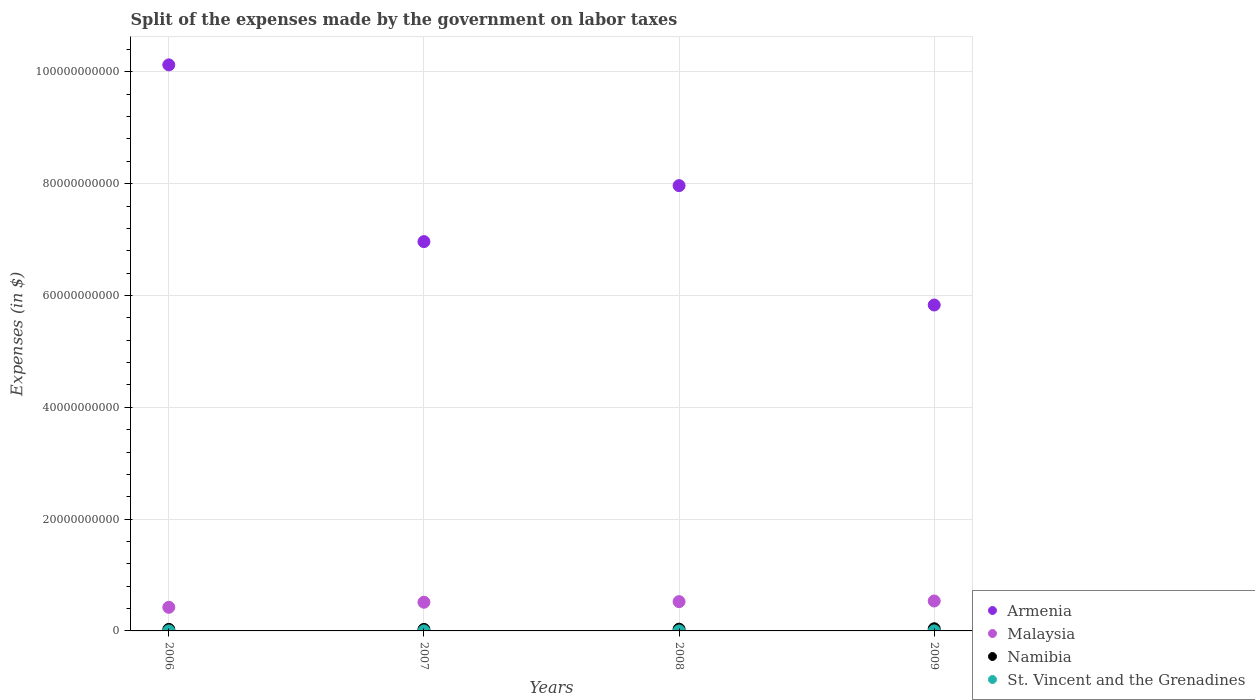What is the expenses made by the government on labor taxes in Malaysia in 2007?
Make the answer very short. 5.13e+09. Across all years, what is the maximum expenses made by the government on labor taxes in Malaysia?
Offer a terse response. 5.35e+09. Across all years, what is the minimum expenses made by the government on labor taxes in St. Vincent and the Grenadines?
Provide a short and direct response. 2.20e+06. In which year was the expenses made by the government on labor taxes in Armenia minimum?
Provide a short and direct response. 2009. What is the total expenses made by the government on labor taxes in St. Vincent and the Grenadines in the graph?
Your answer should be compact. 1.01e+07. What is the difference between the expenses made by the government on labor taxes in Armenia in 2008 and that in 2009?
Give a very brief answer. 2.14e+1. What is the difference between the expenses made by the government on labor taxes in Malaysia in 2006 and the expenses made by the government on labor taxes in Namibia in 2009?
Your answer should be very brief. 3.84e+09. What is the average expenses made by the government on labor taxes in Armenia per year?
Your response must be concise. 7.72e+1. In the year 2009, what is the difference between the expenses made by the government on labor taxes in Armenia and expenses made by the government on labor taxes in St. Vincent and the Grenadines?
Make the answer very short. 5.83e+1. What is the ratio of the expenses made by the government on labor taxes in St. Vincent and the Grenadines in 2007 to that in 2008?
Your response must be concise. 1.18. Is the expenses made by the government on labor taxes in Malaysia in 2006 less than that in 2007?
Make the answer very short. Yes. Is the difference between the expenses made by the government on labor taxes in Armenia in 2006 and 2007 greater than the difference between the expenses made by the government on labor taxes in St. Vincent and the Grenadines in 2006 and 2007?
Provide a succinct answer. Yes. What is the difference between the highest and the second highest expenses made by the government on labor taxes in Malaysia?
Provide a short and direct response. 1.15e+08. What is the difference between the highest and the lowest expenses made by the government on labor taxes in Malaysia?
Provide a succinct answer. 1.13e+09. In how many years, is the expenses made by the government on labor taxes in Malaysia greater than the average expenses made by the government on labor taxes in Malaysia taken over all years?
Make the answer very short. 3. Is it the case that in every year, the sum of the expenses made by the government on labor taxes in Malaysia and expenses made by the government on labor taxes in Armenia  is greater than the sum of expenses made by the government on labor taxes in Namibia and expenses made by the government on labor taxes in St. Vincent and the Grenadines?
Ensure brevity in your answer.  Yes. How many years are there in the graph?
Offer a very short reply. 4. What is the difference between two consecutive major ticks on the Y-axis?
Ensure brevity in your answer.  2.00e+1. Does the graph contain grids?
Your response must be concise. Yes. Where does the legend appear in the graph?
Provide a succinct answer. Bottom right. How many legend labels are there?
Keep it short and to the point. 4. What is the title of the graph?
Your answer should be compact. Split of the expenses made by the government on labor taxes. Does "High income" appear as one of the legend labels in the graph?
Your answer should be very brief. No. What is the label or title of the Y-axis?
Make the answer very short. Expenses (in $). What is the Expenses (in $) in Armenia in 2006?
Offer a very short reply. 1.01e+11. What is the Expenses (in $) in Malaysia in 2006?
Your answer should be compact. 4.23e+09. What is the Expenses (in $) in Namibia in 2006?
Make the answer very short. 2.73e+08. What is the Expenses (in $) of St. Vincent and the Grenadines in 2006?
Make the answer very short. 2.60e+06. What is the Expenses (in $) in Armenia in 2007?
Offer a very short reply. 6.96e+1. What is the Expenses (in $) in Malaysia in 2007?
Your answer should be compact. 5.13e+09. What is the Expenses (in $) in Namibia in 2007?
Provide a succinct answer. 2.68e+08. What is the Expenses (in $) of St. Vincent and the Grenadines in 2007?
Provide a short and direct response. 2.60e+06. What is the Expenses (in $) of Armenia in 2008?
Provide a succinct answer. 7.97e+1. What is the Expenses (in $) in Malaysia in 2008?
Provide a succinct answer. 5.24e+09. What is the Expenses (in $) in Namibia in 2008?
Offer a very short reply. 3.13e+08. What is the Expenses (in $) in St. Vincent and the Grenadines in 2008?
Offer a terse response. 2.20e+06. What is the Expenses (in $) of Armenia in 2009?
Provide a succinct answer. 5.83e+1. What is the Expenses (in $) in Malaysia in 2009?
Ensure brevity in your answer.  5.35e+09. What is the Expenses (in $) in Namibia in 2009?
Give a very brief answer. 3.89e+08. What is the Expenses (in $) of St. Vincent and the Grenadines in 2009?
Your answer should be very brief. 2.70e+06. Across all years, what is the maximum Expenses (in $) in Armenia?
Provide a short and direct response. 1.01e+11. Across all years, what is the maximum Expenses (in $) of Malaysia?
Provide a succinct answer. 5.35e+09. Across all years, what is the maximum Expenses (in $) of Namibia?
Keep it short and to the point. 3.89e+08. Across all years, what is the maximum Expenses (in $) in St. Vincent and the Grenadines?
Make the answer very short. 2.70e+06. Across all years, what is the minimum Expenses (in $) in Armenia?
Your response must be concise. 5.83e+1. Across all years, what is the minimum Expenses (in $) of Malaysia?
Keep it short and to the point. 4.23e+09. Across all years, what is the minimum Expenses (in $) of Namibia?
Give a very brief answer. 2.68e+08. Across all years, what is the minimum Expenses (in $) in St. Vincent and the Grenadines?
Provide a short and direct response. 2.20e+06. What is the total Expenses (in $) of Armenia in the graph?
Your answer should be compact. 3.09e+11. What is the total Expenses (in $) of Malaysia in the graph?
Your answer should be compact. 2.00e+1. What is the total Expenses (in $) in Namibia in the graph?
Ensure brevity in your answer.  1.24e+09. What is the total Expenses (in $) of St. Vincent and the Grenadines in the graph?
Make the answer very short. 1.01e+07. What is the difference between the Expenses (in $) of Armenia in 2006 and that in 2007?
Give a very brief answer. 3.16e+1. What is the difference between the Expenses (in $) in Malaysia in 2006 and that in 2007?
Your answer should be compact. -9.08e+08. What is the difference between the Expenses (in $) in Namibia in 2006 and that in 2007?
Provide a succinct answer. 4.53e+06. What is the difference between the Expenses (in $) in St. Vincent and the Grenadines in 2006 and that in 2007?
Ensure brevity in your answer.  0. What is the difference between the Expenses (in $) in Armenia in 2006 and that in 2008?
Make the answer very short. 2.16e+1. What is the difference between the Expenses (in $) in Malaysia in 2006 and that in 2008?
Offer a terse response. -1.01e+09. What is the difference between the Expenses (in $) in Namibia in 2006 and that in 2008?
Offer a very short reply. -4.08e+07. What is the difference between the Expenses (in $) of St. Vincent and the Grenadines in 2006 and that in 2008?
Offer a very short reply. 4.00e+05. What is the difference between the Expenses (in $) in Armenia in 2006 and that in 2009?
Your response must be concise. 4.30e+1. What is the difference between the Expenses (in $) in Malaysia in 2006 and that in 2009?
Offer a terse response. -1.13e+09. What is the difference between the Expenses (in $) of Namibia in 2006 and that in 2009?
Your response must be concise. -1.16e+08. What is the difference between the Expenses (in $) in Armenia in 2007 and that in 2008?
Give a very brief answer. -1.00e+1. What is the difference between the Expenses (in $) of Malaysia in 2007 and that in 2008?
Make the answer very short. -1.06e+08. What is the difference between the Expenses (in $) of Namibia in 2007 and that in 2008?
Provide a short and direct response. -4.53e+07. What is the difference between the Expenses (in $) in St. Vincent and the Grenadines in 2007 and that in 2008?
Your answer should be compact. 4.00e+05. What is the difference between the Expenses (in $) of Armenia in 2007 and that in 2009?
Offer a very short reply. 1.13e+1. What is the difference between the Expenses (in $) of Malaysia in 2007 and that in 2009?
Provide a short and direct response. -2.21e+08. What is the difference between the Expenses (in $) of Namibia in 2007 and that in 2009?
Make the answer very short. -1.21e+08. What is the difference between the Expenses (in $) in Armenia in 2008 and that in 2009?
Give a very brief answer. 2.14e+1. What is the difference between the Expenses (in $) in Malaysia in 2008 and that in 2009?
Offer a terse response. -1.15e+08. What is the difference between the Expenses (in $) in Namibia in 2008 and that in 2009?
Provide a succinct answer. -7.52e+07. What is the difference between the Expenses (in $) in St. Vincent and the Grenadines in 2008 and that in 2009?
Offer a terse response. -5.00e+05. What is the difference between the Expenses (in $) of Armenia in 2006 and the Expenses (in $) of Malaysia in 2007?
Provide a succinct answer. 9.61e+1. What is the difference between the Expenses (in $) of Armenia in 2006 and the Expenses (in $) of Namibia in 2007?
Make the answer very short. 1.01e+11. What is the difference between the Expenses (in $) in Armenia in 2006 and the Expenses (in $) in St. Vincent and the Grenadines in 2007?
Make the answer very short. 1.01e+11. What is the difference between the Expenses (in $) in Malaysia in 2006 and the Expenses (in $) in Namibia in 2007?
Your answer should be very brief. 3.96e+09. What is the difference between the Expenses (in $) of Malaysia in 2006 and the Expenses (in $) of St. Vincent and the Grenadines in 2007?
Provide a succinct answer. 4.22e+09. What is the difference between the Expenses (in $) in Namibia in 2006 and the Expenses (in $) in St. Vincent and the Grenadines in 2007?
Your response must be concise. 2.70e+08. What is the difference between the Expenses (in $) of Armenia in 2006 and the Expenses (in $) of Malaysia in 2008?
Provide a short and direct response. 9.60e+1. What is the difference between the Expenses (in $) of Armenia in 2006 and the Expenses (in $) of Namibia in 2008?
Give a very brief answer. 1.01e+11. What is the difference between the Expenses (in $) in Armenia in 2006 and the Expenses (in $) in St. Vincent and the Grenadines in 2008?
Your answer should be compact. 1.01e+11. What is the difference between the Expenses (in $) of Malaysia in 2006 and the Expenses (in $) of Namibia in 2008?
Offer a terse response. 3.91e+09. What is the difference between the Expenses (in $) in Malaysia in 2006 and the Expenses (in $) in St. Vincent and the Grenadines in 2008?
Offer a very short reply. 4.22e+09. What is the difference between the Expenses (in $) of Namibia in 2006 and the Expenses (in $) of St. Vincent and the Grenadines in 2008?
Provide a succinct answer. 2.70e+08. What is the difference between the Expenses (in $) of Armenia in 2006 and the Expenses (in $) of Malaysia in 2009?
Your answer should be very brief. 9.59e+1. What is the difference between the Expenses (in $) of Armenia in 2006 and the Expenses (in $) of Namibia in 2009?
Offer a terse response. 1.01e+11. What is the difference between the Expenses (in $) of Armenia in 2006 and the Expenses (in $) of St. Vincent and the Grenadines in 2009?
Keep it short and to the point. 1.01e+11. What is the difference between the Expenses (in $) of Malaysia in 2006 and the Expenses (in $) of Namibia in 2009?
Ensure brevity in your answer.  3.84e+09. What is the difference between the Expenses (in $) of Malaysia in 2006 and the Expenses (in $) of St. Vincent and the Grenadines in 2009?
Make the answer very short. 4.22e+09. What is the difference between the Expenses (in $) of Namibia in 2006 and the Expenses (in $) of St. Vincent and the Grenadines in 2009?
Offer a terse response. 2.70e+08. What is the difference between the Expenses (in $) of Armenia in 2007 and the Expenses (in $) of Malaysia in 2008?
Offer a very short reply. 6.44e+1. What is the difference between the Expenses (in $) of Armenia in 2007 and the Expenses (in $) of Namibia in 2008?
Give a very brief answer. 6.93e+1. What is the difference between the Expenses (in $) of Armenia in 2007 and the Expenses (in $) of St. Vincent and the Grenadines in 2008?
Provide a succinct answer. 6.96e+1. What is the difference between the Expenses (in $) of Malaysia in 2007 and the Expenses (in $) of Namibia in 2008?
Make the answer very short. 4.82e+09. What is the difference between the Expenses (in $) of Malaysia in 2007 and the Expenses (in $) of St. Vincent and the Grenadines in 2008?
Provide a succinct answer. 5.13e+09. What is the difference between the Expenses (in $) of Namibia in 2007 and the Expenses (in $) of St. Vincent and the Grenadines in 2008?
Your answer should be compact. 2.66e+08. What is the difference between the Expenses (in $) in Armenia in 2007 and the Expenses (in $) in Malaysia in 2009?
Offer a very short reply. 6.43e+1. What is the difference between the Expenses (in $) in Armenia in 2007 and the Expenses (in $) in Namibia in 2009?
Offer a terse response. 6.93e+1. What is the difference between the Expenses (in $) of Armenia in 2007 and the Expenses (in $) of St. Vincent and the Grenadines in 2009?
Your answer should be very brief. 6.96e+1. What is the difference between the Expenses (in $) of Malaysia in 2007 and the Expenses (in $) of Namibia in 2009?
Offer a very short reply. 4.74e+09. What is the difference between the Expenses (in $) of Malaysia in 2007 and the Expenses (in $) of St. Vincent and the Grenadines in 2009?
Your answer should be compact. 5.13e+09. What is the difference between the Expenses (in $) in Namibia in 2007 and the Expenses (in $) in St. Vincent and the Grenadines in 2009?
Offer a very short reply. 2.65e+08. What is the difference between the Expenses (in $) of Armenia in 2008 and the Expenses (in $) of Malaysia in 2009?
Offer a very short reply. 7.43e+1. What is the difference between the Expenses (in $) of Armenia in 2008 and the Expenses (in $) of Namibia in 2009?
Your response must be concise. 7.93e+1. What is the difference between the Expenses (in $) in Armenia in 2008 and the Expenses (in $) in St. Vincent and the Grenadines in 2009?
Ensure brevity in your answer.  7.96e+1. What is the difference between the Expenses (in $) of Malaysia in 2008 and the Expenses (in $) of Namibia in 2009?
Keep it short and to the point. 4.85e+09. What is the difference between the Expenses (in $) of Malaysia in 2008 and the Expenses (in $) of St. Vincent and the Grenadines in 2009?
Offer a very short reply. 5.24e+09. What is the difference between the Expenses (in $) of Namibia in 2008 and the Expenses (in $) of St. Vincent and the Grenadines in 2009?
Provide a succinct answer. 3.11e+08. What is the average Expenses (in $) of Armenia per year?
Your response must be concise. 7.72e+1. What is the average Expenses (in $) of Malaysia per year?
Provide a succinct answer. 4.99e+09. What is the average Expenses (in $) in Namibia per year?
Ensure brevity in your answer.  3.11e+08. What is the average Expenses (in $) in St. Vincent and the Grenadines per year?
Your answer should be compact. 2.52e+06. In the year 2006, what is the difference between the Expenses (in $) of Armenia and Expenses (in $) of Malaysia?
Make the answer very short. 9.70e+1. In the year 2006, what is the difference between the Expenses (in $) in Armenia and Expenses (in $) in Namibia?
Give a very brief answer. 1.01e+11. In the year 2006, what is the difference between the Expenses (in $) in Armenia and Expenses (in $) in St. Vincent and the Grenadines?
Provide a succinct answer. 1.01e+11. In the year 2006, what is the difference between the Expenses (in $) of Malaysia and Expenses (in $) of Namibia?
Offer a very short reply. 3.95e+09. In the year 2006, what is the difference between the Expenses (in $) in Malaysia and Expenses (in $) in St. Vincent and the Grenadines?
Your answer should be compact. 4.22e+09. In the year 2006, what is the difference between the Expenses (in $) of Namibia and Expenses (in $) of St. Vincent and the Grenadines?
Keep it short and to the point. 2.70e+08. In the year 2007, what is the difference between the Expenses (in $) in Armenia and Expenses (in $) in Malaysia?
Keep it short and to the point. 6.45e+1. In the year 2007, what is the difference between the Expenses (in $) in Armenia and Expenses (in $) in Namibia?
Make the answer very short. 6.94e+1. In the year 2007, what is the difference between the Expenses (in $) of Armenia and Expenses (in $) of St. Vincent and the Grenadines?
Offer a terse response. 6.96e+1. In the year 2007, what is the difference between the Expenses (in $) in Malaysia and Expenses (in $) in Namibia?
Give a very brief answer. 4.87e+09. In the year 2007, what is the difference between the Expenses (in $) in Malaysia and Expenses (in $) in St. Vincent and the Grenadines?
Provide a short and direct response. 5.13e+09. In the year 2007, what is the difference between the Expenses (in $) in Namibia and Expenses (in $) in St. Vincent and the Grenadines?
Offer a very short reply. 2.65e+08. In the year 2008, what is the difference between the Expenses (in $) in Armenia and Expenses (in $) in Malaysia?
Your answer should be very brief. 7.44e+1. In the year 2008, what is the difference between the Expenses (in $) in Armenia and Expenses (in $) in Namibia?
Keep it short and to the point. 7.93e+1. In the year 2008, what is the difference between the Expenses (in $) in Armenia and Expenses (in $) in St. Vincent and the Grenadines?
Offer a terse response. 7.96e+1. In the year 2008, what is the difference between the Expenses (in $) of Malaysia and Expenses (in $) of Namibia?
Your answer should be compact. 4.93e+09. In the year 2008, what is the difference between the Expenses (in $) of Malaysia and Expenses (in $) of St. Vincent and the Grenadines?
Make the answer very short. 5.24e+09. In the year 2008, what is the difference between the Expenses (in $) in Namibia and Expenses (in $) in St. Vincent and the Grenadines?
Your answer should be compact. 3.11e+08. In the year 2009, what is the difference between the Expenses (in $) of Armenia and Expenses (in $) of Malaysia?
Provide a short and direct response. 5.29e+1. In the year 2009, what is the difference between the Expenses (in $) in Armenia and Expenses (in $) in Namibia?
Keep it short and to the point. 5.79e+1. In the year 2009, what is the difference between the Expenses (in $) of Armenia and Expenses (in $) of St. Vincent and the Grenadines?
Ensure brevity in your answer.  5.83e+1. In the year 2009, what is the difference between the Expenses (in $) of Malaysia and Expenses (in $) of Namibia?
Make the answer very short. 4.97e+09. In the year 2009, what is the difference between the Expenses (in $) in Malaysia and Expenses (in $) in St. Vincent and the Grenadines?
Your answer should be very brief. 5.35e+09. In the year 2009, what is the difference between the Expenses (in $) of Namibia and Expenses (in $) of St. Vincent and the Grenadines?
Your answer should be very brief. 3.86e+08. What is the ratio of the Expenses (in $) in Armenia in 2006 to that in 2007?
Ensure brevity in your answer.  1.45. What is the ratio of the Expenses (in $) of Malaysia in 2006 to that in 2007?
Your response must be concise. 0.82. What is the ratio of the Expenses (in $) in Namibia in 2006 to that in 2007?
Ensure brevity in your answer.  1.02. What is the ratio of the Expenses (in $) in St. Vincent and the Grenadines in 2006 to that in 2007?
Offer a terse response. 1. What is the ratio of the Expenses (in $) in Armenia in 2006 to that in 2008?
Keep it short and to the point. 1.27. What is the ratio of the Expenses (in $) in Malaysia in 2006 to that in 2008?
Your answer should be compact. 0.81. What is the ratio of the Expenses (in $) of Namibia in 2006 to that in 2008?
Offer a very short reply. 0.87. What is the ratio of the Expenses (in $) in St. Vincent and the Grenadines in 2006 to that in 2008?
Your answer should be very brief. 1.18. What is the ratio of the Expenses (in $) of Armenia in 2006 to that in 2009?
Offer a very short reply. 1.74. What is the ratio of the Expenses (in $) of Malaysia in 2006 to that in 2009?
Provide a succinct answer. 0.79. What is the ratio of the Expenses (in $) in Namibia in 2006 to that in 2009?
Offer a very short reply. 0.7. What is the ratio of the Expenses (in $) of Armenia in 2007 to that in 2008?
Keep it short and to the point. 0.87. What is the ratio of the Expenses (in $) of Malaysia in 2007 to that in 2008?
Your response must be concise. 0.98. What is the ratio of the Expenses (in $) in Namibia in 2007 to that in 2008?
Offer a very short reply. 0.86. What is the ratio of the Expenses (in $) in St. Vincent and the Grenadines in 2007 to that in 2008?
Your answer should be very brief. 1.18. What is the ratio of the Expenses (in $) of Armenia in 2007 to that in 2009?
Your response must be concise. 1.19. What is the ratio of the Expenses (in $) of Malaysia in 2007 to that in 2009?
Offer a terse response. 0.96. What is the ratio of the Expenses (in $) of Namibia in 2007 to that in 2009?
Your answer should be compact. 0.69. What is the ratio of the Expenses (in $) of Armenia in 2008 to that in 2009?
Your response must be concise. 1.37. What is the ratio of the Expenses (in $) in Malaysia in 2008 to that in 2009?
Your answer should be very brief. 0.98. What is the ratio of the Expenses (in $) in Namibia in 2008 to that in 2009?
Provide a succinct answer. 0.81. What is the ratio of the Expenses (in $) in St. Vincent and the Grenadines in 2008 to that in 2009?
Make the answer very short. 0.81. What is the difference between the highest and the second highest Expenses (in $) of Armenia?
Ensure brevity in your answer.  2.16e+1. What is the difference between the highest and the second highest Expenses (in $) of Malaysia?
Your answer should be very brief. 1.15e+08. What is the difference between the highest and the second highest Expenses (in $) in Namibia?
Offer a terse response. 7.52e+07. What is the difference between the highest and the second highest Expenses (in $) in St. Vincent and the Grenadines?
Make the answer very short. 1.00e+05. What is the difference between the highest and the lowest Expenses (in $) in Armenia?
Offer a terse response. 4.30e+1. What is the difference between the highest and the lowest Expenses (in $) of Malaysia?
Your answer should be compact. 1.13e+09. What is the difference between the highest and the lowest Expenses (in $) in Namibia?
Provide a succinct answer. 1.21e+08. What is the difference between the highest and the lowest Expenses (in $) in St. Vincent and the Grenadines?
Offer a very short reply. 5.00e+05. 